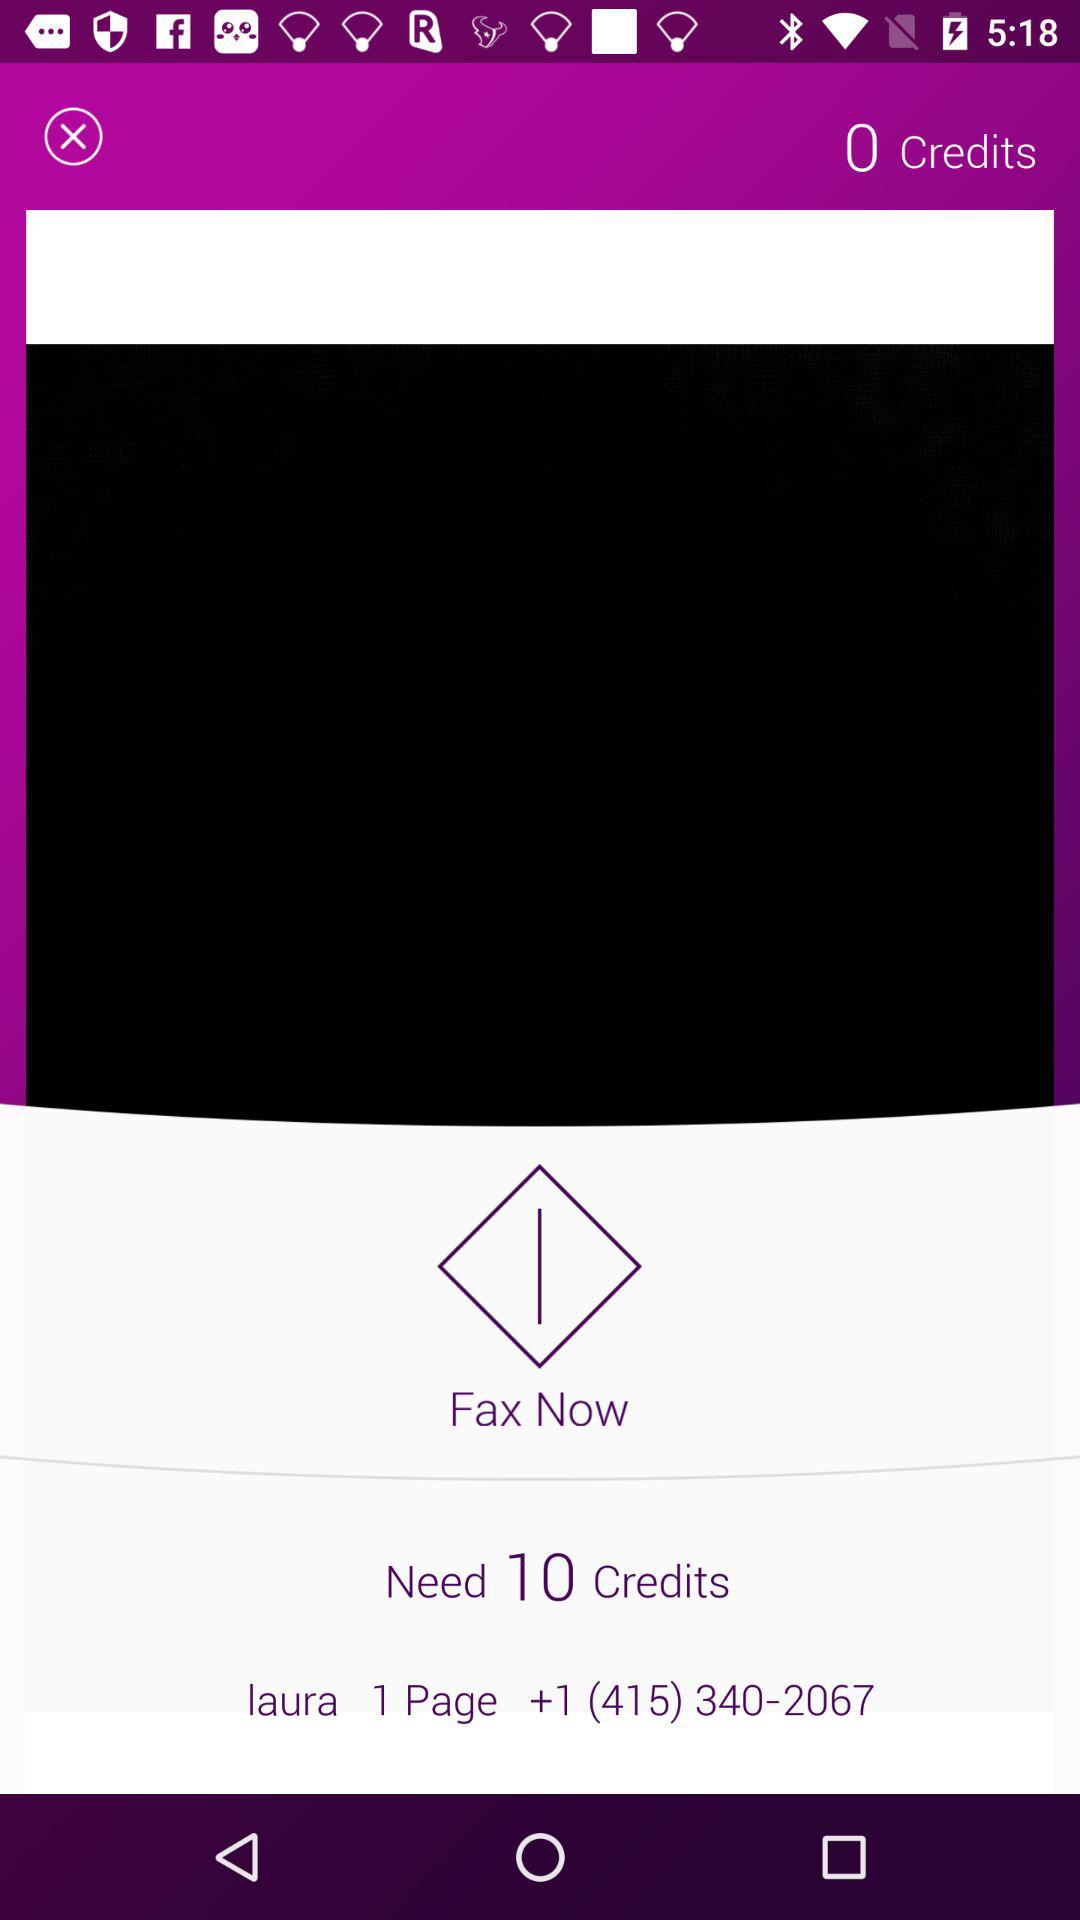How many credits are needed to fax a page?
Answer the question using a single word or phrase. 10 